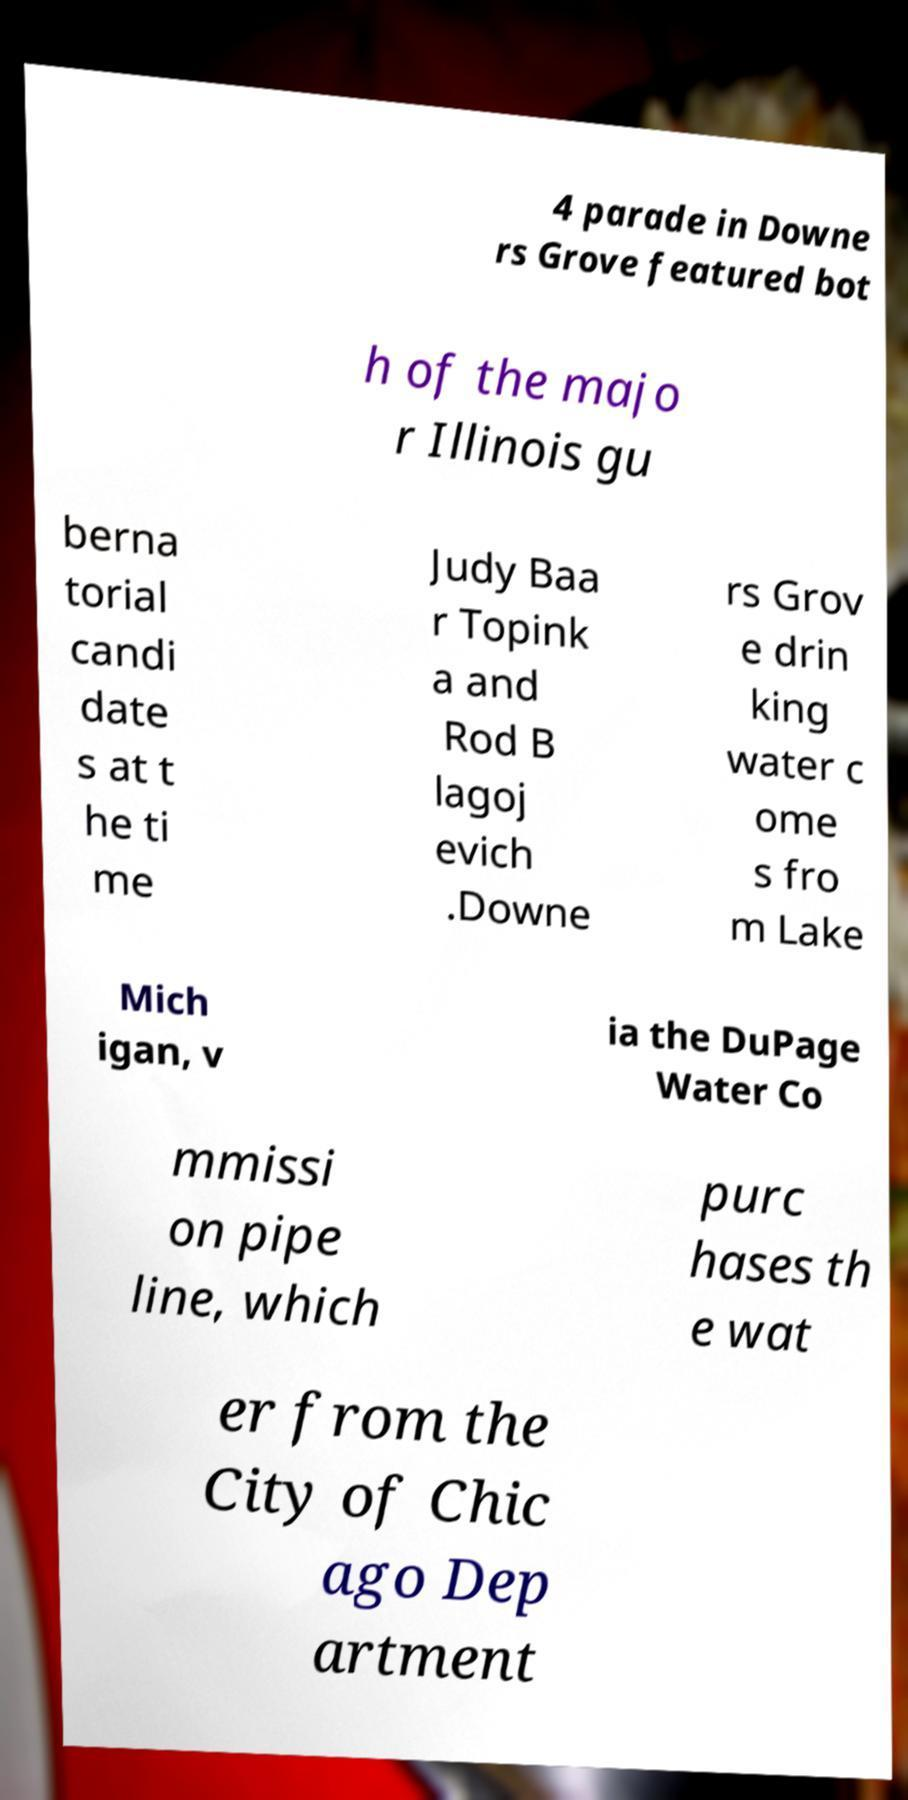For documentation purposes, I need the text within this image transcribed. Could you provide that? 4 parade in Downe rs Grove featured bot h of the majo r Illinois gu berna torial candi date s at t he ti me Judy Baa r Topink a and Rod B lagoj evich .Downe rs Grov e drin king water c ome s fro m Lake Mich igan, v ia the DuPage Water Co mmissi on pipe line, which purc hases th e wat er from the City of Chic ago Dep artment 